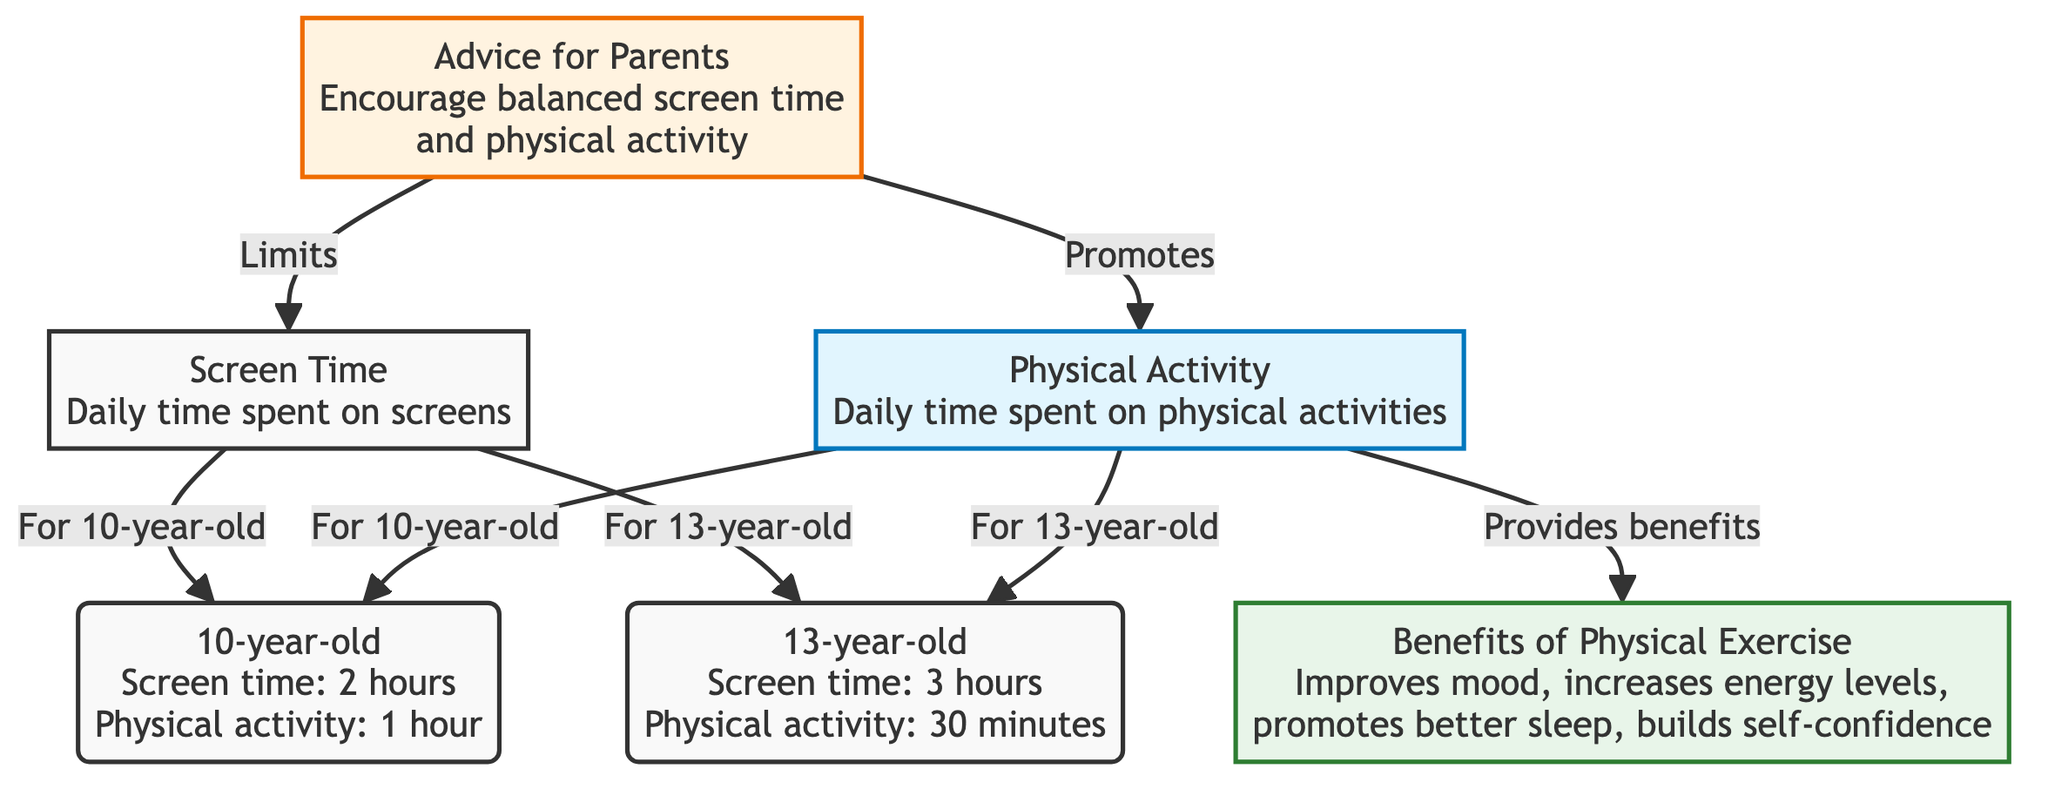What is the daily screen time for the 10-year-old? The diagram shows that the daily screen time for the 10-year-old is specifically listed under the node for the 10-year-old, which states "Screen time: 2 hours."
Answer: 2 hours How much physical activity does the 13-year-old engage in daily? The physical activity time for the 13-year-old can be found under its corresponding node, which states "Physical activity: 30 minutes."
Answer: 30 minutes What are the benefits of physical exercise indicated in the diagram? The diagram lists multiple benefits under the node "Benefits of Physical Exercise," which specifically mentions improving mood, increasing energy levels, promoting better sleep, and building self-confidence.
Answer: Improves mood, increases energy levels, promotes better sleep, builds self-confidence Which age group has more physical activity time according to the diagram? To answer this, we compare the physical activity times for both age groups. The 10-year-old has 1 hour of physical activity, while the 13-year-old has only 30 minutes. Thus, the 10-year-old has more.
Answer: 10-year-old What advice is given for parents in managing screen time and physical activity? The advice for parents can be found in the node labeled "Advice for Parents," which states to "Encourage balanced screen time and physical activity." This indicates the recommended approach for managing both aspects.
Answer: Encourage balanced screen time and physical activity How many hours of screen time does the 13-year-old have compared to the 10-year-old? The diagram presents the screen time of the 10-year-old as 2 hours and the 13-year-old as 3 hours. Therefore, the 13-year-old has 1 hour more of screen time than the 10-year-old.
Answer: 1 hour more What is the relationship between physical activity and benefits in the diagram? The diagram establishes a connection where physical activity is shown to lead to the benefits listed. The node for "Benefits of Physical Exercise" is connected to physical activity indicating that engaging in physical activity provides those benefits.
Answer: Leads to benefits How many total nodes are present in this diagram? To count the total number of nodes, we identify each labeled element in the diagram, which totals up to 6 distinct nodes displayed in the flowchart.
Answer: 6 nodes 